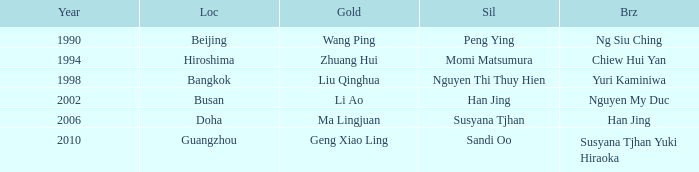What's the lowest Year with the Location of Bangkok? 1998.0. 